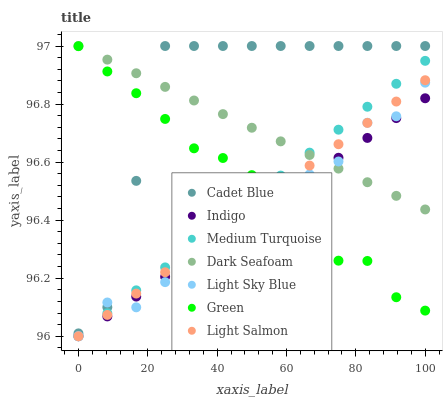Does Indigo have the minimum area under the curve?
Answer yes or no. Yes. Does Cadet Blue have the maximum area under the curve?
Answer yes or no. Yes. Does Cadet Blue have the minimum area under the curve?
Answer yes or no. No. Does Indigo have the maximum area under the curve?
Answer yes or no. No. Is Medium Turquoise the smoothest?
Answer yes or no. Yes. Is Cadet Blue the roughest?
Answer yes or no. Yes. Is Indigo the smoothest?
Answer yes or no. No. Is Indigo the roughest?
Answer yes or no. No. Does Light Salmon have the lowest value?
Answer yes or no. Yes. Does Cadet Blue have the lowest value?
Answer yes or no. No. Does Dark Seafoam have the highest value?
Answer yes or no. Yes. Does Indigo have the highest value?
Answer yes or no. No. Is Green less than Dark Seafoam?
Answer yes or no. Yes. Is Cadet Blue greater than Indigo?
Answer yes or no. Yes. Does Cadet Blue intersect Dark Seafoam?
Answer yes or no. Yes. Is Cadet Blue less than Dark Seafoam?
Answer yes or no. No. Is Cadet Blue greater than Dark Seafoam?
Answer yes or no. No. Does Green intersect Dark Seafoam?
Answer yes or no. No. 